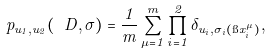Convert formula to latex. <formula><loc_0><loc_0><loc_500><loc_500>p _ { u _ { 1 } , u _ { 2 } } ( \ D , \sigma ) = \frac { 1 } { m } \sum _ { \mu = 1 } ^ { m } \prod _ { i = 1 } ^ { 2 } \delta _ { u _ { i } , \sigma _ { i } ( \i x _ { i } ^ { \mu } ) } ,</formula> 